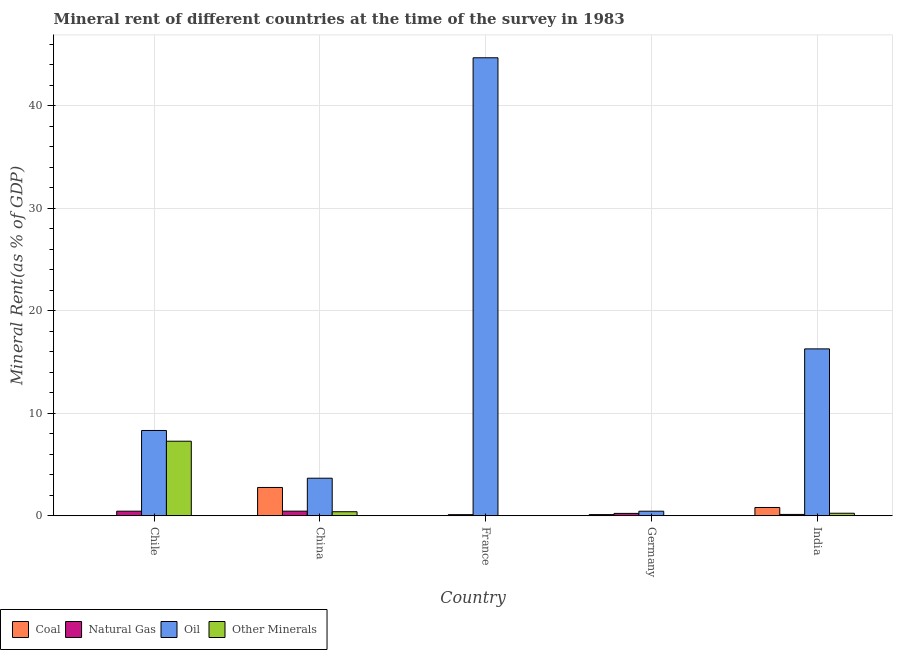Are the number of bars on each tick of the X-axis equal?
Keep it short and to the point. Yes. What is the label of the 3rd group of bars from the left?
Provide a succinct answer. France. In how many cases, is the number of bars for a given country not equal to the number of legend labels?
Your answer should be compact. 0. What is the natural gas rent in India?
Give a very brief answer. 0.13. Across all countries, what is the maximum coal rent?
Your answer should be compact. 2.76. Across all countries, what is the minimum coal rent?
Ensure brevity in your answer.  0.01. What is the total  rent of other minerals in the graph?
Your response must be concise. 7.94. What is the difference between the natural gas rent in China and that in France?
Keep it short and to the point. 0.34. What is the difference between the  rent of other minerals in Chile and the oil rent in Germany?
Ensure brevity in your answer.  6.83. What is the average oil rent per country?
Keep it short and to the point. 14.67. What is the difference between the oil rent and  rent of other minerals in India?
Ensure brevity in your answer.  16.03. What is the ratio of the  rent of other minerals in France to that in India?
Make the answer very short. 0.05. Is the difference between the  rent of other minerals in China and Germany greater than the difference between the coal rent in China and Germany?
Make the answer very short. No. What is the difference between the highest and the second highest coal rent?
Provide a succinct answer. 1.95. What is the difference between the highest and the lowest coal rent?
Ensure brevity in your answer.  2.75. In how many countries, is the coal rent greater than the average coal rent taken over all countries?
Keep it short and to the point. 2. Is it the case that in every country, the sum of the natural gas rent and coal rent is greater than the sum of  rent of other minerals and oil rent?
Your answer should be compact. No. What does the 3rd bar from the left in India represents?
Provide a succinct answer. Oil. What does the 1st bar from the right in Germany represents?
Provide a short and direct response. Other Minerals. What is the difference between two consecutive major ticks on the Y-axis?
Give a very brief answer. 10. Does the graph contain grids?
Offer a terse response. Yes. How are the legend labels stacked?
Provide a short and direct response. Horizontal. What is the title of the graph?
Your answer should be very brief. Mineral rent of different countries at the time of the survey in 1983. Does "Coal" appear as one of the legend labels in the graph?
Provide a short and direct response. Yes. What is the label or title of the Y-axis?
Make the answer very short. Mineral Rent(as % of GDP). What is the Mineral Rent(as % of GDP) in Coal in Chile?
Provide a succinct answer. 0.02. What is the Mineral Rent(as % of GDP) of Natural Gas in Chile?
Your response must be concise. 0.45. What is the Mineral Rent(as % of GDP) of Oil in Chile?
Offer a very short reply. 8.32. What is the Mineral Rent(as % of GDP) in Other Minerals in Chile?
Offer a very short reply. 7.27. What is the Mineral Rent(as % of GDP) of Coal in China?
Your response must be concise. 2.76. What is the Mineral Rent(as % of GDP) in Natural Gas in China?
Your answer should be very brief. 0.45. What is the Mineral Rent(as % of GDP) in Oil in China?
Make the answer very short. 3.66. What is the Mineral Rent(as % of GDP) of Other Minerals in China?
Provide a succinct answer. 0.4. What is the Mineral Rent(as % of GDP) of Coal in France?
Provide a succinct answer. 0.01. What is the Mineral Rent(as % of GDP) of Natural Gas in France?
Your answer should be compact. 0.11. What is the Mineral Rent(as % of GDP) of Oil in France?
Your answer should be very brief. 44.66. What is the Mineral Rent(as % of GDP) of Other Minerals in France?
Your answer should be compact. 0.01. What is the Mineral Rent(as % of GDP) of Coal in Germany?
Ensure brevity in your answer.  0.12. What is the Mineral Rent(as % of GDP) in Natural Gas in Germany?
Provide a succinct answer. 0.23. What is the Mineral Rent(as % of GDP) in Oil in Germany?
Keep it short and to the point. 0.45. What is the Mineral Rent(as % of GDP) in Other Minerals in Germany?
Your answer should be very brief. 0.01. What is the Mineral Rent(as % of GDP) of Coal in India?
Offer a terse response. 0.81. What is the Mineral Rent(as % of GDP) in Natural Gas in India?
Provide a short and direct response. 0.13. What is the Mineral Rent(as % of GDP) in Oil in India?
Your answer should be very brief. 16.27. What is the Mineral Rent(as % of GDP) in Other Minerals in India?
Offer a very short reply. 0.25. Across all countries, what is the maximum Mineral Rent(as % of GDP) in Coal?
Your answer should be compact. 2.76. Across all countries, what is the maximum Mineral Rent(as % of GDP) in Natural Gas?
Give a very brief answer. 0.45. Across all countries, what is the maximum Mineral Rent(as % of GDP) in Oil?
Give a very brief answer. 44.66. Across all countries, what is the maximum Mineral Rent(as % of GDP) in Other Minerals?
Offer a very short reply. 7.27. Across all countries, what is the minimum Mineral Rent(as % of GDP) of Coal?
Make the answer very short. 0.01. Across all countries, what is the minimum Mineral Rent(as % of GDP) of Natural Gas?
Provide a succinct answer. 0.11. Across all countries, what is the minimum Mineral Rent(as % of GDP) of Oil?
Your response must be concise. 0.45. Across all countries, what is the minimum Mineral Rent(as % of GDP) of Other Minerals?
Provide a short and direct response. 0.01. What is the total Mineral Rent(as % of GDP) of Coal in the graph?
Offer a very short reply. 3.73. What is the total Mineral Rent(as % of GDP) of Natural Gas in the graph?
Offer a very short reply. 1.38. What is the total Mineral Rent(as % of GDP) of Oil in the graph?
Offer a terse response. 73.36. What is the total Mineral Rent(as % of GDP) of Other Minerals in the graph?
Offer a terse response. 7.94. What is the difference between the Mineral Rent(as % of GDP) of Coal in Chile and that in China?
Give a very brief answer. -2.74. What is the difference between the Mineral Rent(as % of GDP) of Natural Gas in Chile and that in China?
Provide a succinct answer. -0. What is the difference between the Mineral Rent(as % of GDP) in Oil in Chile and that in China?
Give a very brief answer. 4.65. What is the difference between the Mineral Rent(as % of GDP) of Other Minerals in Chile and that in China?
Give a very brief answer. 6.88. What is the difference between the Mineral Rent(as % of GDP) in Coal in Chile and that in France?
Keep it short and to the point. 0.01. What is the difference between the Mineral Rent(as % of GDP) of Natural Gas in Chile and that in France?
Keep it short and to the point. 0.34. What is the difference between the Mineral Rent(as % of GDP) of Oil in Chile and that in France?
Your response must be concise. -36.34. What is the difference between the Mineral Rent(as % of GDP) in Other Minerals in Chile and that in France?
Offer a terse response. 7.26. What is the difference between the Mineral Rent(as % of GDP) in Coal in Chile and that in Germany?
Offer a very short reply. -0.1. What is the difference between the Mineral Rent(as % of GDP) of Natural Gas in Chile and that in Germany?
Offer a very short reply. 0.22. What is the difference between the Mineral Rent(as % of GDP) of Oil in Chile and that in Germany?
Give a very brief answer. 7.87. What is the difference between the Mineral Rent(as % of GDP) in Other Minerals in Chile and that in Germany?
Your response must be concise. 7.27. What is the difference between the Mineral Rent(as % of GDP) of Coal in Chile and that in India?
Provide a succinct answer. -0.79. What is the difference between the Mineral Rent(as % of GDP) of Natural Gas in Chile and that in India?
Your response must be concise. 0.32. What is the difference between the Mineral Rent(as % of GDP) of Oil in Chile and that in India?
Offer a very short reply. -7.95. What is the difference between the Mineral Rent(as % of GDP) in Other Minerals in Chile and that in India?
Give a very brief answer. 7.02. What is the difference between the Mineral Rent(as % of GDP) in Coal in China and that in France?
Provide a succinct answer. 2.75. What is the difference between the Mineral Rent(as % of GDP) in Natural Gas in China and that in France?
Keep it short and to the point. 0.34. What is the difference between the Mineral Rent(as % of GDP) in Oil in China and that in France?
Give a very brief answer. -40.99. What is the difference between the Mineral Rent(as % of GDP) of Other Minerals in China and that in France?
Your answer should be very brief. 0.38. What is the difference between the Mineral Rent(as % of GDP) of Coal in China and that in Germany?
Your response must be concise. 2.65. What is the difference between the Mineral Rent(as % of GDP) of Natural Gas in China and that in Germany?
Your answer should be very brief. 0.22. What is the difference between the Mineral Rent(as % of GDP) in Oil in China and that in Germany?
Your response must be concise. 3.22. What is the difference between the Mineral Rent(as % of GDP) in Other Minerals in China and that in Germany?
Provide a short and direct response. 0.39. What is the difference between the Mineral Rent(as % of GDP) of Coal in China and that in India?
Your answer should be compact. 1.95. What is the difference between the Mineral Rent(as % of GDP) in Natural Gas in China and that in India?
Your answer should be very brief. 0.32. What is the difference between the Mineral Rent(as % of GDP) of Oil in China and that in India?
Provide a short and direct response. -12.61. What is the difference between the Mineral Rent(as % of GDP) of Other Minerals in China and that in India?
Your answer should be compact. 0.15. What is the difference between the Mineral Rent(as % of GDP) of Coal in France and that in Germany?
Your answer should be compact. -0.1. What is the difference between the Mineral Rent(as % of GDP) in Natural Gas in France and that in Germany?
Give a very brief answer. -0.12. What is the difference between the Mineral Rent(as % of GDP) in Oil in France and that in Germany?
Ensure brevity in your answer.  44.21. What is the difference between the Mineral Rent(as % of GDP) in Other Minerals in France and that in Germany?
Provide a succinct answer. 0.01. What is the difference between the Mineral Rent(as % of GDP) in Coal in France and that in India?
Provide a succinct answer. -0.8. What is the difference between the Mineral Rent(as % of GDP) of Natural Gas in France and that in India?
Offer a very short reply. -0.02. What is the difference between the Mineral Rent(as % of GDP) in Oil in France and that in India?
Ensure brevity in your answer.  28.38. What is the difference between the Mineral Rent(as % of GDP) of Other Minerals in France and that in India?
Provide a short and direct response. -0.24. What is the difference between the Mineral Rent(as % of GDP) of Coal in Germany and that in India?
Ensure brevity in your answer.  -0.7. What is the difference between the Mineral Rent(as % of GDP) of Natural Gas in Germany and that in India?
Offer a terse response. 0.1. What is the difference between the Mineral Rent(as % of GDP) in Oil in Germany and that in India?
Make the answer very short. -15.83. What is the difference between the Mineral Rent(as % of GDP) of Other Minerals in Germany and that in India?
Your answer should be very brief. -0.24. What is the difference between the Mineral Rent(as % of GDP) of Coal in Chile and the Mineral Rent(as % of GDP) of Natural Gas in China?
Offer a very short reply. -0.43. What is the difference between the Mineral Rent(as % of GDP) in Coal in Chile and the Mineral Rent(as % of GDP) in Oil in China?
Give a very brief answer. -3.64. What is the difference between the Mineral Rent(as % of GDP) of Coal in Chile and the Mineral Rent(as % of GDP) of Other Minerals in China?
Keep it short and to the point. -0.38. What is the difference between the Mineral Rent(as % of GDP) in Natural Gas in Chile and the Mineral Rent(as % of GDP) in Oil in China?
Make the answer very short. -3.21. What is the difference between the Mineral Rent(as % of GDP) in Natural Gas in Chile and the Mineral Rent(as % of GDP) in Other Minerals in China?
Your answer should be compact. 0.05. What is the difference between the Mineral Rent(as % of GDP) of Oil in Chile and the Mineral Rent(as % of GDP) of Other Minerals in China?
Make the answer very short. 7.92. What is the difference between the Mineral Rent(as % of GDP) in Coal in Chile and the Mineral Rent(as % of GDP) in Natural Gas in France?
Provide a short and direct response. -0.09. What is the difference between the Mineral Rent(as % of GDP) of Coal in Chile and the Mineral Rent(as % of GDP) of Oil in France?
Offer a very short reply. -44.64. What is the difference between the Mineral Rent(as % of GDP) in Coal in Chile and the Mineral Rent(as % of GDP) in Other Minerals in France?
Keep it short and to the point. 0.01. What is the difference between the Mineral Rent(as % of GDP) in Natural Gas in Chile and the Mineral Rent(as % of GDP) in Oil in France?
Make the answer very short. -44.21. What is the difference between the Mineral Rent(as % of GDP) in Natural Gas in Chile and the Mineral Rent(as % of GDP) in Other Minerals in France?
Offer a terse response. 0.44. What is the difference between the Mineral Rent(as % of GDP) of Oil in Chile and the Mineral Rent(as % of GDP) of Other Minerals in France?
Your answer should be very brief. 8.31. What is the difference between the Mineral Rent(as % of GDP) of Coal in Chile and the Mineral Rent(as % of GDP) of Natural Gas in Germany?
Offer a terse response. -0.21. What is the difference between the Mineral Rent(as % of GDP) of Coal in Chile and the Mineral Rent(as % of GDP) of Oil in Germany?
Your answer should be compact. -0.43. What is the difference between the Mineral Rent(as % of GDP) in Coal in Chile and the Mineral Rent(as % of GDP) in Other Minerals in Germany?
Provide a short and direct response. 0.01. What is the difference between the Mineral Rent(as % of GDP) in Natural Gas in Chile and the Mineral Rent(as % of GDP) in Oil in Germany?
Offer a very short reply. 0. What is the difference between the Mineral Rent(as % of GDP) in Natural Gas in Chile and the Mineral Rent(as % of GDP) in Other Minerals in Germany?
Provide a short and direct response. 0.44. What is the difference between the Mineral Rent(as % of GDP) in Oil in Chile and the Mineral Rent(as % of GDP) in Other Minerals in Germany?
Your answer should be compact. 8.31. What is the difference between the Mineral Rent(as % of GDP) in Coal in Chile and the Mineral Rent(as % of GDP) in Natural Gas in India?
Your answer should be compact. -0.11. What is the difference between the Mineral Rent(as % of GDP) of Coal in Chile and the Mineral Rent(as % of GDP) of Oil in India?
Offer a terse response. -16.25. What is the difference between the Mineral Rent(as % of GDP) in Coal in Chile and the Mineral Rent(as % of GDP) in Other Minerals in India?
Provide a short and direct response. -0.23. What is the difference between the Mineral Rent(as % of GDP) of Natural Gas in Chile and the Mineral Rent(as % of GDP) of Oil in India?
Your response must be concise. -15.82. What is the difference between the Mineral Rent(as % of GDP) in Natural Gas in Chile and the Mineral Rent(as % of GDP) in Other Minerals in India?
Keep it short and to the point. 0.2. What is the difference between the Mineral Rent(as % of GDP) of Oil in Chile and the Mineral Rent(as % of GDP) of Other Minerals in India?
Make the answer very short. 8.07. What is the difference between the Mineral Rent(as % of GDP) of Coal in China and the Mineral Rent(as % of GDP) of Natural Gas in France?
Give a very brief answer. 2.65. What is the difference between the Mineral Rent(as % of GDP) in Coal in China and the Mineral Rent(as % of GDP) in Oil in France?
Your response must be concise. -41.89. What is the difference between the Mineral Rent(as % of GDP) in Coal in China and the Mineral Rent(as % of GDP) in Other Minerals in France?
Offer a very short reply. 2.75. What is the difference between the Mineral Rent(as % of GDP) in Natural Gas in China and the Mineral Rent(as % of GDP) in Oil in France?
Your answer should be compact. -44.2. What is the difference between the Mineral Rent(as % of GDP) of Natural Gas in China and the Mineral Rent(as % of GDP) of Other Minerals in France?
Your answer should be very brief. 0.44. What is the difference between the Mineral Rent(as % of GDP) in Oil in China and the Mineral Rent(as % of GDP) in Other Minerals in France?
Offer a terse response. 3.65. What is the difference between the Mineral Rent(as % of GDP) in Coal in China and the Mineral Rent(as % of GDP) in Natural Gas in Germany?
Offer a terse response. 2.53. What is the difference between the Mineral Rent(as % of GDP) in Coal in China and the Mineral Rent(as % of GDP) in Oil in Germany?
Provide a short and direct response. 2.32. What is the difference between the Mineral Rent(as % of GDP) of Coal in China and the Mineral Rent(as % of GDP) of Other Minerals in Germany?
Provide a succinct answer. 2.76. What is the difference between the Mineral Rent(as % of GDP) in Natural Gas in China and the Mineral Rent(as % of GDP) in Oil in Germany?
Provide a succinct answer. 0.01. What is the difference between the Mineral Rent(as % of GDP) in Natural Gas in China and the Mineral Rent(as % of GDP) in Other Minerals in Germany?
Your answer should be compact. 0.45. What is the difference between the Mineral Rent(as % of GDP) in Oil in China and the Mineral Rent(as % of GDP) in Other Minerals in Germany?
Offer a very short reply. 3.66. What is the difference between the Mineral Rent(as % of GDP) of Coal in China and the Mineral Rent(as % of GDP) of Natural Gas in India?
Your answer should be compact. 2.63. What is the difference between the Mineral Rent(as % of GDP) in Coal in China and the Mineral Rent(as % of GDP) in Oil in India?
Make the answer very short. -13.51. What is the difference between the Mineral Rent(as % of GDP) in Coal in China and the Mineral Rent(as % of GDP) in Other Minerals in India?
Offer a terse response. 2.51. What is the difference between the Mineral Rent(as % of GDP) of Natural Gas in China and the Mineral Rent(as % of GDP) of Oil in India?
Make the answer very short. -15.82. What is the difference between the Mineral Rent(as % of GDP) of Natural Gas in China and the Mineral Rent(as % of GDP) of Other Minerals in India?
Keep it short and to the point. 0.2. What is the difference between the Mineral Rent(as % of GDP) in Oil in China and the Mineral Rent(as % of GDP) in Other Minerals in India?
Your answer should be very brief. 3.42. What is the difference between the Mineral Rent(as % of GDP) in Coal in France and the Mineral Rent(as % of GDP) in Natural Gas in Germany?
Your response must be concise. -0.22. What is the difference between the Mineral Rent(as % of GDP) of Coal in France and the Mineral Rent(as % of GDP) of Oil in Germany?
Your answer should be very brief. -0.43. What is the difference between the Mineral Rent(as % of GDP) in Coal in France and the Mineral Rent(as % of GDP) in Other Minerals in Germany?
Provide a succinct answer. 0.01. What is the difference between the Mineral Rent(as % of GDP) in Natural Gas in France and the Mineral Rent(as % of GDP) in Oil in Germany?
Your answer should be very brief. -0.34. What is the difference between the Mineral Rent(as % of GDP) in Natural Gas in France and the Mineral Rent(as % of GDP) in Other Minerals in Germany?
Make the answer very short. 0.1. What is the difference between the Mineral Rent(as % of GDP) in Oil in France and the Mineral Rent(as % of GDP) in Other Minerals in Germany?
Make the answer very short. 44.65. What is the difference between the Mineral Rent(as % of GDP) of Coal in France and the Mineral Rent(as % of GDP) of Natural Gas in India?
Ensure brevity in your answer.  -0.12. What is the difference between the Mineral Rent(as % of GDP) of Coal in France and the Mineral Rent(as % of GDP) of Oil in India?
Your answer should be very brief. -16.26. What is the difference between the Mineral Rent(as % of GDP) in Coal in France and the Mineral Rent(as % of GDP) in Other Minerals in India?
Give a very brief answer. -0.23. What is the difference between the Mineral Rent(as % of GDP) in Natural Gas in France and the Mineral Rent(as % of GDP) in Oil in India?
Keep it short and to the point. -16.16. What is the difference between the Mineral Rent(as % of GDP) in Natural Gas in France and the Mineral Rent(as % of GDP) in Other Minerals in India?
Provide a succinct answer. -0.14. What is the difference between the Mineral Rent(as % of GDP) of Oil in France and the Mineral Rent(as % of GDP) of Other Minerals in India?
Provide a succinct answer. 44.41. What is the difference between the Mineral Rent(as % of GDP) of Coal in Germany and the Mineral Rent(as % of GDP) of Natural Gas in India?
Provide a short and direct response. -0.02. What is the difference between the Mineral Rent(as % of GDP) of Coal in Germany and the Mineral Rent(as % of GDP) of Oil in India?
Make the answer very short. -16.16. What is the difference between the Mineral Rent(as % of GDP) in Coal in Germany and the Mineral Rent(as % of GDP) in Other Minerals in India?
Ensure brevity in your answer.  -0.13. What is the difference between the Mineral Rent(as % of GDP) of Natural Gas in Germany and the Mineral Rent(as % of GDP) of Oil in India?
Ensure brevity in your answer.  -16.04. What is the difference between the Mineral Rent(as % of GDP) of Natural Gas in Germany and the Mineral Rent(as % of GDP) of Other Minerals in India?
Keep it short and to the point. -0.01. What is the difference between the Mineral Rent(as % of GDP) of Oil in Germany and the Mineral Rent(as % of GDP) of Other Minerals in India?
Your answer should be compact. 0.2. What is the average Mineral Rent(as % of GDP) in Coal per country?
Keep it short and to the point. 0.75. What is the average Mineral Rent(as % of GDP) in Natural Gas per country?
Your answer should be compact. 0.28. What is the average Mineral Rent(as % of GDP) in Oil per country?
Your answer should be compact. 14.67. What is the average Mineral Rent(as % of GDP) in Other Minerals per country?
Your answer should be very brief. 1.59. What is the difference between the Mineral Rent(as % of GDP) of Coal and Mineral Rent(as % of GDP) of Natural Gas in Chile?
Your answer should be very brief. -0.43. What is the difference between the Mineral Rent(as % of GDP) of Coal and Mineral Rent(as % of GDP) of Oil in Chile?
Your answer should be compact. -8.3. What is the difference between the Mineral Rent(as % of GDP) of Coal and Mineral Rent(as % of GDP) of Other Minerals in Chile?
Your answer should be very brief. -7.25. What is the difference between the Mineral Rent(as % of GDP) of Natural Gas and Mineral Rent(as % of GDP) of Oil in Chile?
Your answer should be compact. -7.87. What is the difference between the Mineral Rent(as % of GDP) in Natural Gas and Mineral Rent(as % of GDP) in Other Minerals in Chile?
Your answer should be very brief. -6.82. What is the difference between the Mineral Rent(as % of GDP) in Oil and Mineral Rent(as % of GDP) in Other Minerals in Chile?
Your answer should be compact. 1.05. What is the difference between the Mineral Rent(as % of GDP) of Coal and Mineral Rent(as % of GDP) of Natural Gas in China?
Ensure brevity in your answer.  2.31. What is the difference between the Mineral Rent(as % of GDP) in Coal and Mineral Rent(as % of GDP) in Oil in China?
Offer a very short reply. -0.9. What is the difference between the Mineral Rent(as % of GDP) of Coal and Mineral Rent(as % of GDP) of Other Minerals in China?
Make the answer very short. 2.37. What is the difference between the Mineral Rent(as % of GDP) in Natural Gas and Mineral Rent(as % of GDP) in Oil in China?
Ensure brevity in your answer.  -3.21. What is the difference between the Mineral Rent(as % of GDP) of Natural Gas and Mineral Rent(as % of GDP) of Other Minerals in China?
Provide a succinct answer. 0.06. What is the difference between the Mineral Rent(as % of GDP) of Oil and Mineral Rent(as % of GDP) of Other Minerals in China?
Your response must be concise. 3.27. What is the difference between the Mineral Rent(as % of GDP) of Coal and Mineral Rent(as % of GDP) of Natural Gas in France?
Your answer should be very brief. -0.1. What is the difference between the Mineral Rent(as % of GDP) of Coal and Mineral Rent(as % of GDP) of Oil in France?
Ensure brevity in your answer.  -44.64. What is the difference between the Mineral Rent(as % of GDP) of Coal and Mineral Rent(as % of GDP) of Other Minerals in France?
Provide a short and direct response. 0. What is the difference between the Mineral Rent(as % of GDP) in Natural Gas and Mineral Rent(as % of GDP) in Oil in France?
Give a very brief answer. -44.55. What is the difference between the Mineral Rent(as % of GDP) in Natural Gas and Mineral Rent(as % of GDP) in Other Minerals in France?
Keep it short and to the point. 0.1. What is the difference between the Mineral Rent(as % of GDP) in Oil and Mineral Rent(as % of GDP) in Other Minerals in France?
Make the answer very short. 44.65. What is the difference between the Mineral Rent(as % of GDP) in Coal and Mineral Rent(as % of GDP) in Natural Gas in Germany?
Give a very brief answer. -0.12. What is the difference between the Mineral Rent(as % of GDP) in Coal and Mineral Rent(as % of GDP) in Oil in Germany?
Make the answer very short. -0.33. What is the difference between the Mineral Rent(as % of GDP) of Coal and Mineral Rent(as % of GDP) of Other Minerals in Germany?
Your answer should be compact. 0.11. What is the difference between the Mineral Rent(as % of GDP) in Natural Gas and Mineral Rent(as % of GDP) in Oil in Germany?
Your answer should be very brief. -0.21. What is the difference between the Mineral Rent(as % of GDP) in Natural Gas and Mineral Rent(as % of GDP) in Other Minerals in Germany?
Provide a short and direct response. 0.23. What is the difference between the Mineral Rent(as % of GDP) of Oil and Mineral Rent(as % of GDP) of Other Minerals in Germany?
Your response must be concise. 0.44. What is the difference between the Mineral Rent(as % of GDP) of Coal and Mineral Rent(as % of GDP) of Natural Gas in India?
Your answer should be compact. 0.68. What is the difference between the Mineral Rent(as % of GDP) in Coal and Mineral Rent(as % of GDP) in Oil in India?
Offer a very short reply. -15.46. What is the difference between the Mineral Rent(as % of GDP) of Coal and Mineral Rent(as % of GDP) of Other Minerals in India?
Offer a terse response. 0.56. What is the difference between the Mineral Rent(as % of GDP) in Natural Gas and Mineral Rent(as % of GDP) in Oil in India?
Make the answer very short. -16.14. What is the difference between the Mineral Rent(as % of GDP) in Natural Gas and Mineral Rent(as % of GDP) in Other Minerals in India?
Offer a terse response. -0.12. What is the difference between the Mineral Rent(as % of GDP) of Oil and Mineral Rent(as % of GDP) of Other Minerals in India?
Your response must be concise. 16.02. What is the ratio of the Mineral Rent(as % of GDP) of Coal in Chile to that in China?
Your answer should be compact. 0.01. What is the ratio of the Mineral Rent(as % of GDP) of Oil in Chile to that in China?
Your answer should be compact. 2.27. What is the ratio of the Mineral Rent(as % of GDP) in Other Minerals in Chile to that in China?
Provide a short and direct response. 18.35. What is the ratio of the Mineral Rent(as % of GDP) of Coal in Chile to that in France?
Your answer should be very brief. 1.41. What is the ratio of the Mineral Rent(as % of GDP) of Natural Gas in Chile to that in France?
Offer a terse response. 4.09. What is the ratio of the Mineral Rent(as % of GDP) of Oil in Chile to that in France?
Ensure brevity in your answer.  0.19. What is the ratio of the Mineral Rent(as % of GDP) in Other Minerals in Chile to that in France?
Your answer should be very brief. 628.13. What is the ratio of the Mineral Rent(as % of GDP) in Coal in Chile to that in Germany?
Offer a terse response. 0.18. What is the ratio of the Mineral Rent(as % of GDP) of Natural Gas in Chile to that in Germany?
Make the answer very short. 1.93. What is the ratio of the Mineral Rent(as % of GDP) of Oil in Chile to that in Germany?
Ensure brevity in your answer.  18.63. What is the ratio of the Mineral Rent(as % of GDP) of Other Minerals in Chile to that in Germany?
Offer a very short reply. 1152.02. What is the ratio of the Mineral Rent(as % of GDP) of Coal in Chile to that in India?
Ensure brevity in your answer.  0.03. What is the ratio of the Mineral Rent(as % of GDP) of Natural Gas in Chile to that in India?
Keep it short and to the point. 3.39. What is the ratio of the Mineral Rent(as % of GDP) of Oil in Chile to that in India?
Provide a succinct answer. 0.51. What is the ratio of the Mineral Rent(as % of GDP) of Other Minerals in Chile to that in India?
Ensure brevity in your answer.  29.29. What is the ratio of the Mineral Rent(as % of GDP) in Coal in China to that in France?
Provide a succinct answer. 189.03. What is the ratio of the Mineral Rent(as % of GDP) of Natural Gas in China to that in France?
Your response must be concise. 4.11. What is the ratio of the Mineral Rent(as % of GDP) of Oil in China to that in France?
Provide a short and direct response. 0.08. What is the ratio of the Mineral Rent(as % of GDP) of Other Minerals in China to that in France?
Provide a succinct answer. 34.24. What is the ratio of the Mineral Rent(as % of GDP) in Coal in China to that in Germany?
Ensure brevity in your answer.  23.79. What is the ratio of the Mineral Rent(as % of GDP) in Natural Gas in China to that in Germany?
Provide a succinct answer. 1.93. What is the ratio of the Mineral Rent(as % of GDP) of Oil in China to that in Germany?
Offer a terse response. 8.21. What is the ratio of the Mineral Rent(as % of GDP) of Other Minerals in China to that in Germany?
Keep it short and to the point. 62.79. What is the ratio of the Mineral Rent(as % of GDP) of Coal in China to that in India?
Offer a terse response. 3.4. What is the ratio of the Mineral Rent(as % of GDP) of Natural Gas in China to that in India?
Make the answer very short. 3.41. What is the ratio of the Mineral Rent(as % of GDP) in Oil in China to that in India?
Provide a succinct answer. 0.23. What is the ratio of the Mineral Rent(as % of GDP) of Other Minerals in China to that in India?
Offer a terse response. 1.6. What is the ratio of the Mineral Rent(as % of GDP) of Coal in France to that in Germany?
Your answer should be very brief. 0.13. What is the ratio of the Mineral Rent(as % of GDP) in Natural Gas in France to that in Germany?
Ensure brevity in your answer.  0.47. What is the ratio of the Mineral Rent(as % of GDP) of Oil in France to that in Germany?
Provide a succinct answer. 100.03. What is the ratio of the Mineral Rent(as % of GDP) in Other Minerals in France to that in Germany?
Offer a terse response. 1.83. What is the ratio of the Mineral Rent(as % of GDP) of Coal in France to that in India?
Keep it short and to the point. 0.02. What is the ratio of the Mineral Rent(as % of GDP) in Natural Gas in France to that in India?
Make the answer very short. 0.83. What is the ratio of the Mineral Rent(as % of GDP) of Oil in France to that in India?
Your answer should be very brief. 2.74. What is the ratio of the Mineral Rent(as % of GDP) of Other Minerals in France to that in India?
Provide a short and direct response. 0.05. What is the ratio of the Mineral Rent(as % of GDP) in Coal in Germany to that in India?
Your answer should be compact. 0.14. What is the ratio of the Mineral Rent(as % of GDP) of Natural Gas in Germany to that in India?
Your response must be concise. 1.76. What is the ratio of the Mineral Rent(as % of GDP) in Oil in Germany to that in India?
Offer a terse response. 0.03. What is the ratio of the Mineral Rent(as % of GDP) of Other Minerals in Germany to that in India?
Your response must be concise. 0.03. What is the difference between the highest and the second highest Mineral Rent(as % of GDP) in Coal?
Keep it short and to the point. 1.95. What is the difference between the highest and the second highest Mineral Rent(as % of GDP) in Natural Gas?
Make the answer very short. 0. What is the difference between the highest and the second highest Mineral Rent(as % of GDP) in Oil?
Offer a very short reply. 28.38. What is the difference between the highest and the second highest Mineral Rent(as % of GDP) of Other Minerals?
Offer a very short reply. 6.88. What is the difference between the highest and the lowest Mineral Rent(as % of GDP) of Coal?
Provide a short and direct response. 2.75. What is the difference between the highest and the lowest Mineral Rent(as % of GDP) in Natural Gas?
Provide a succinct answer. 0.34. What is the difference between the highest and the lowest Mineral Rent(as % of GDP) in Oil?
Provide a short and direct response. 44.21. What is the difference between the highest and the lowest Mineral Rent(as % of GDP) in Other Minerals?
Keep it short and to the point. 7.27. 